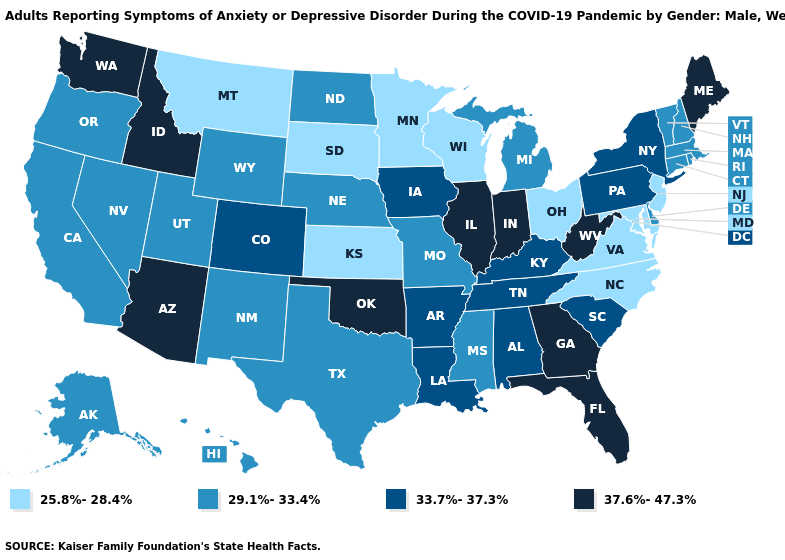What is the lowest value in states that border South Carolina?
Be succinct. 25.8%-28.4%. Does Mississippi have the highest value in the South?
Short answer required. No. Is the legend a continuous bar?
Write a very short answer. No. What is the value of Missouri?
Answer briefly. 29.1%-33.4%. Name the states that have a value in the range 33.7%-37.3%?
Keep it brief. Alabama, Arkansas, Colorado, Iowa, Kentucky, Louisiana, New York, Pennsylvania, South Carolina, Tennessee. Which states have the lowest value in the USA?
Short answer required. Kansas, Maryland, Minnesota, Montana, New Jersey, North Carolina, Ohio, South Dakota, Virginia, Wisconsin. What is the value of Indiana?
Concise answer only. 37.6%-47.3%. What is the value of Mississippi?
Give a very brief answer. 29.1%-33.4%. Which states have the lowest value in the USA?
Give a very brief answer. Kansas, Maryland, Minnesota, Montana, New Jersey, North Carolina, Ohio, South Dakota, Virginia, Wisconsin. Does the map have missing data?
Write a very short answer. No. What is the value of Maryland?
Keep it brief. 25.8%-28.4%. What is the lowest value in the West?
Be succinct. 25.8%-28.4%. Does the map have missing data?
Write a very short answer. No. 